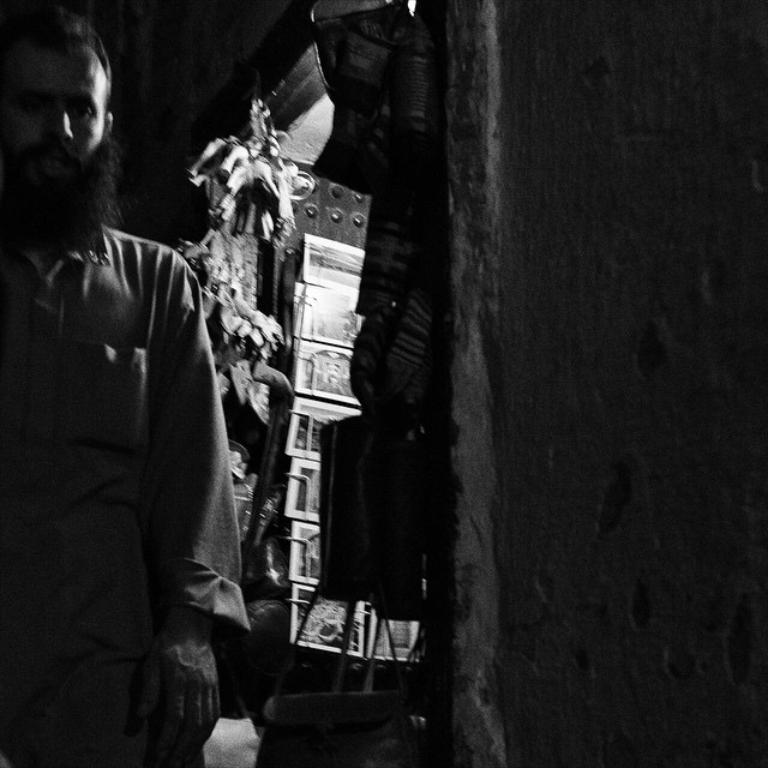What is the main subject of the image? There is a person in the image, truncated towards the left. What can be seen behind the person? There are objects behind the person. What type of structure is visible in the image? There is a wall in the image, truncated towards the right. What type of pain is the person experiencing in the image? There is no indication of pain in the image; it only shows a person and some objects and a wall. Can you see a boat in the image? No, there is no boat present in the image. 